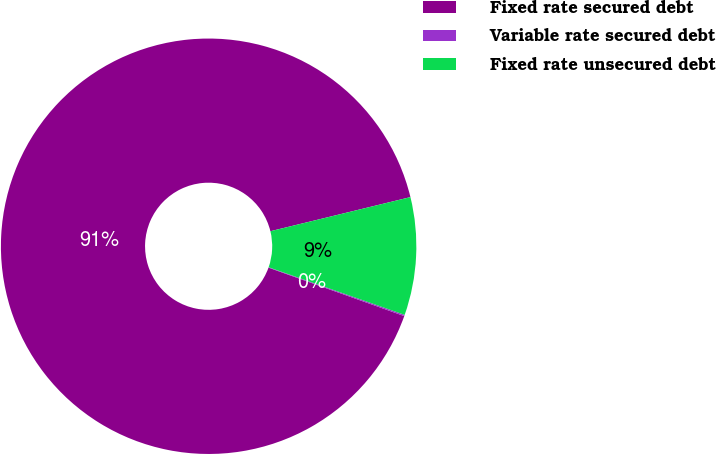Convert chart. <chart><loc_0><loc_0><loc_500><loc_500><pie_chart><fcel>Fixed rate secured debt<fcel>Variable rate secured debt<fcel>Fixed rate unsecured debt<nl><fcel>90.74%<fcel>0.1%<fcel>9.16%<nl></chart> 